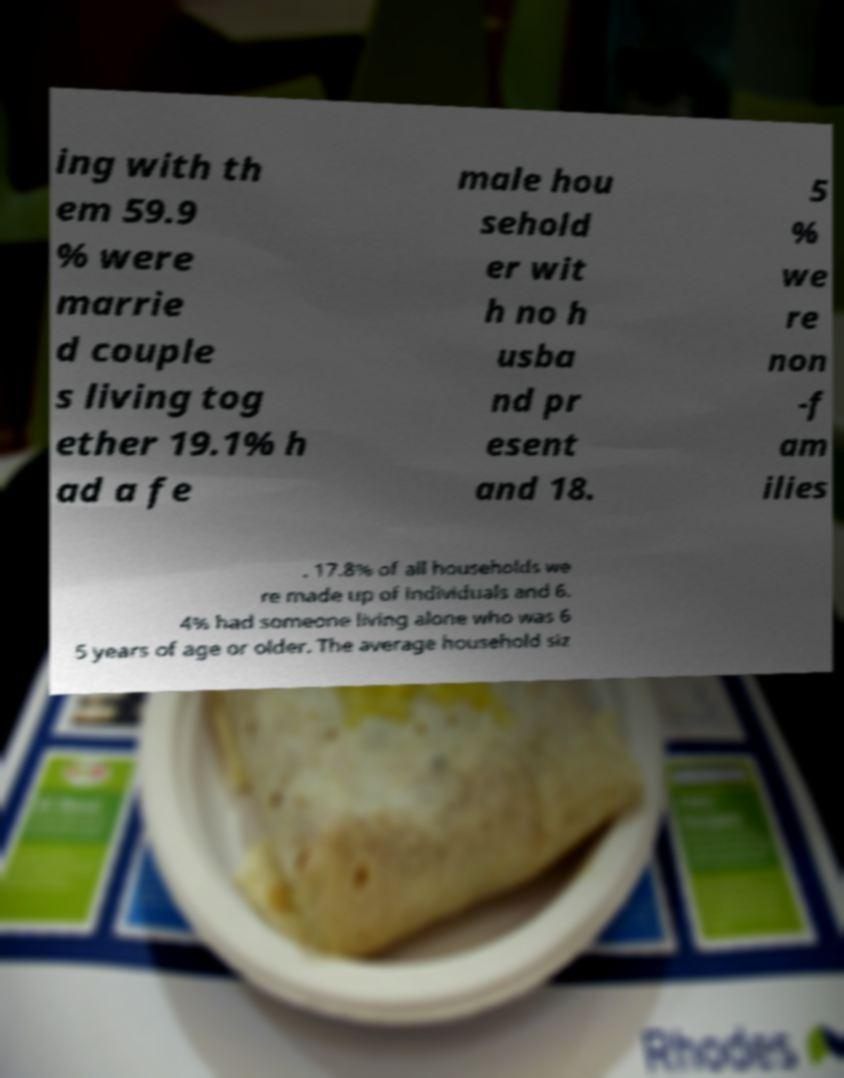Please identify and transcribe the text found in this image. ing with th em 59.9 % were marrie d couple s living tog ether 19.1% h ad a fe male hou sehold er wit h no h usba nd pr esent and 18. 5 % we re non -f am ilies . 17.8% of all households we re made up of individuals and 6. 4% had someone living alone who was 6 5 years of age or older. The average household siz 